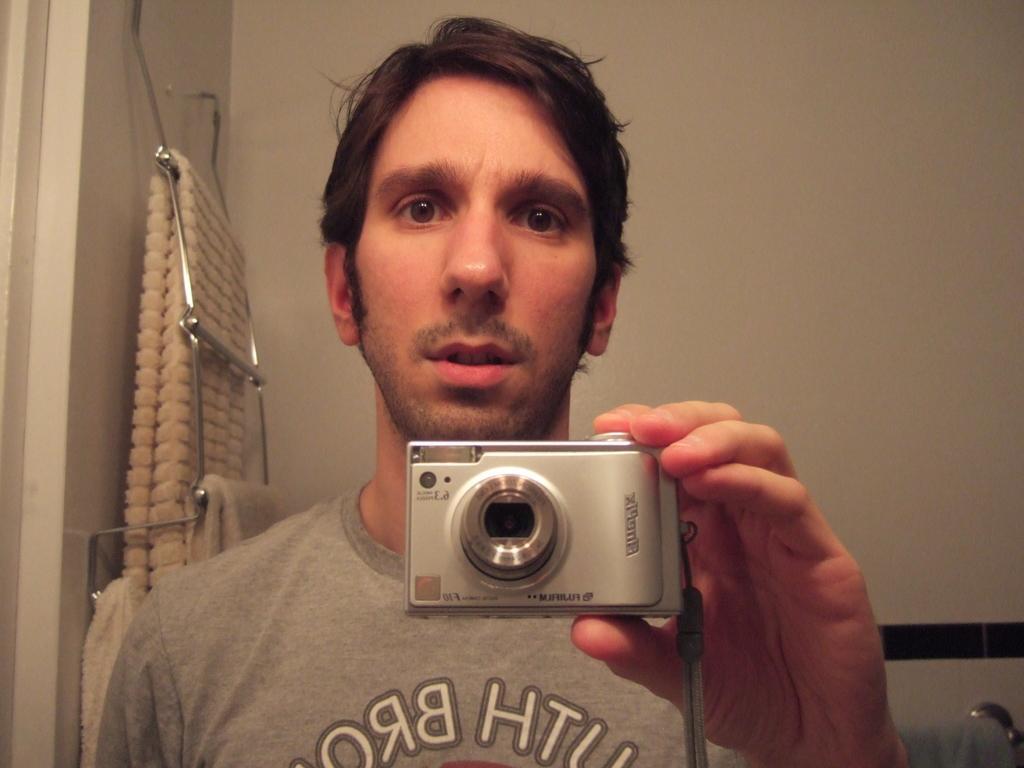Describe this image in one or two sentences. In this image there is a person wearing T-shirt holding camera in his hand. 